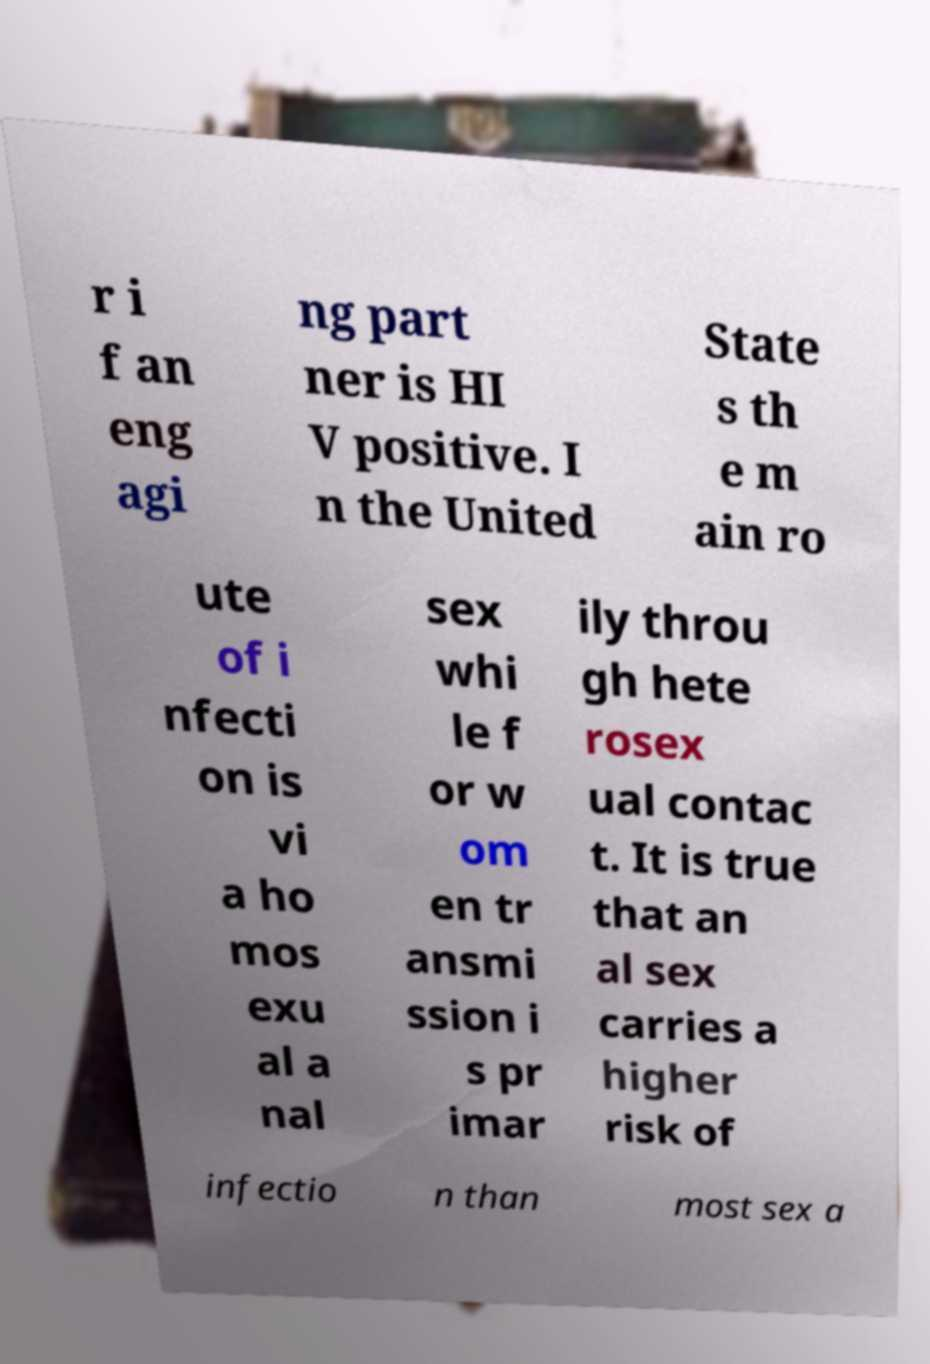For documentation purposes, I need the text within this image transcribed. Could you provide that? r i f an eng agi ng part ner is HI V positive. I n the United State s th e m ain ro ute of i nfecti on is vi a ho mos exu al a nal sex whi le f or w om en tr ansmi ssion i s pr imar ily throu gh hete rosex ual contac t. It is true that an al sex carries a higher risk of infectio n than most sex a 